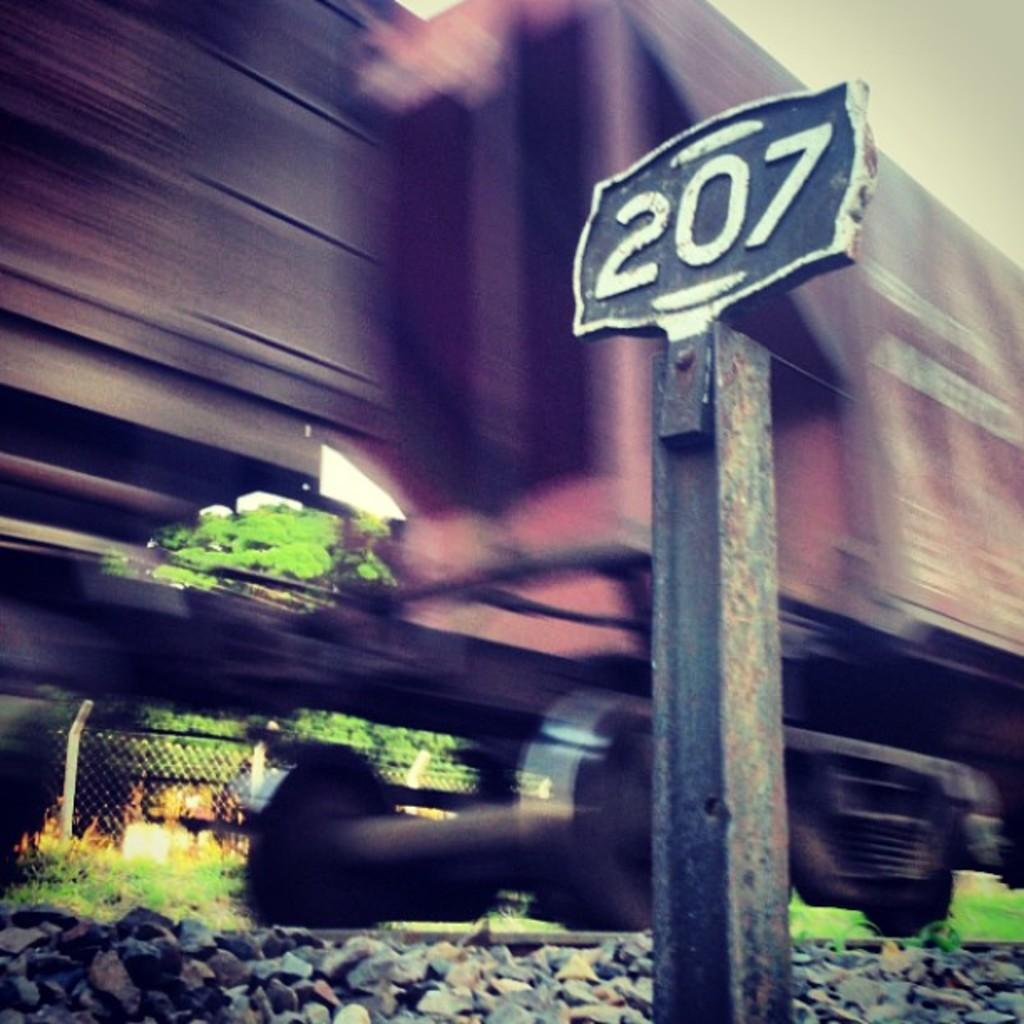What is the main subject of the image? The main subject of the image is a train on the track. What else can be seen in the image besides the train? There is a board, stones, trees, a fence, and the sky visible in the image. Can you describe the background of the image? The background of the image includes trees, a fence, and the sky. What is the train's position in relation to the other elements in the image? The train is on the track, which is located in the foreground of the image. What type of design can be seen on the floor in the image? There is no floor present in the image; it features a train on a track with a background that includes trees, a fence, and the sky. 